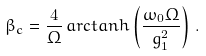Convert formula to latex. <formula><loc_0><loc_0><loc_500><loc_500>\beta _ { c } = \frac { 4 } { \Omega } \, a r c t a n h \left ( \frac { \omega _ { 0 } \Omega } { g _ { 1 } ^ { 2 } } \right ) \, .</formula> 